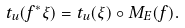<formula> <loc_0><loc_0><loc_500><loc_500>t _ { u } ( f ^ { * } \xi ) = t _ { u } ( \xi ) \circ M _ { E } ( f ) .</formula> 